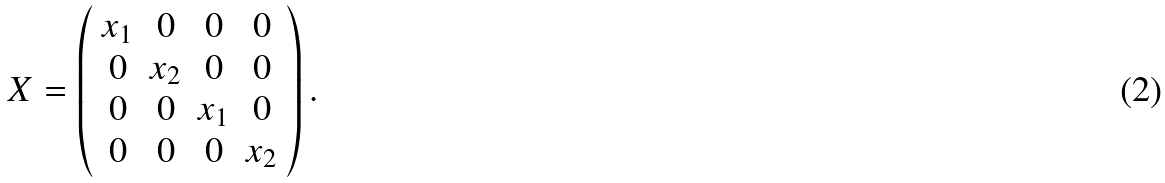Convert formula to latex. <formula><loc_0><loc_0><loc_500><loc_500>X = \left ( \begin{array} { c c c c } x _ { 1 } & 0 & 0 & 0 \\ 0 & x _ { 2 } & 0 & 0 \\ 0 & 0 & x _ { 1 } & 0 \\ 0 & 0 & 0 & x _ { 2 } \end{array} \right ) .</formula> 